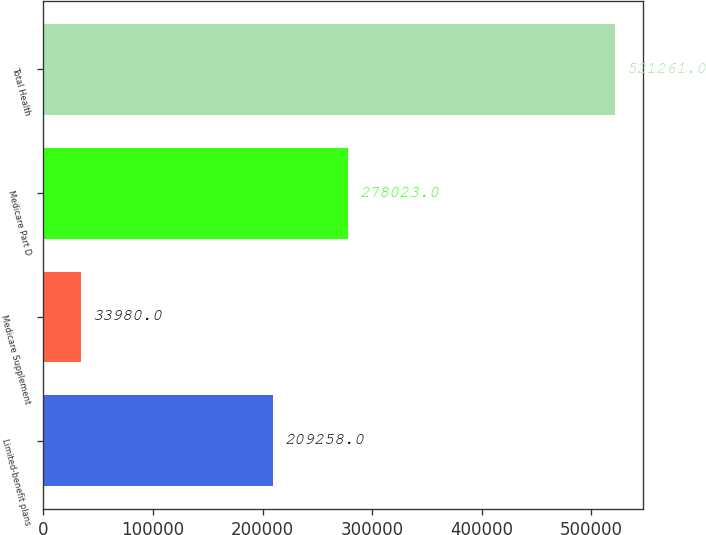Convert chart. <chart><loc_0><loc_0><loc_500><loc_500><bar_chart><fcel>Limited-benefit plans<fcel>Medicare Supplement<fcel>Medicare Part D<fcel>Total Health<nl><fcel>209258<fcel>33980<fcel>278023<fcel>521261<nl></chart> 